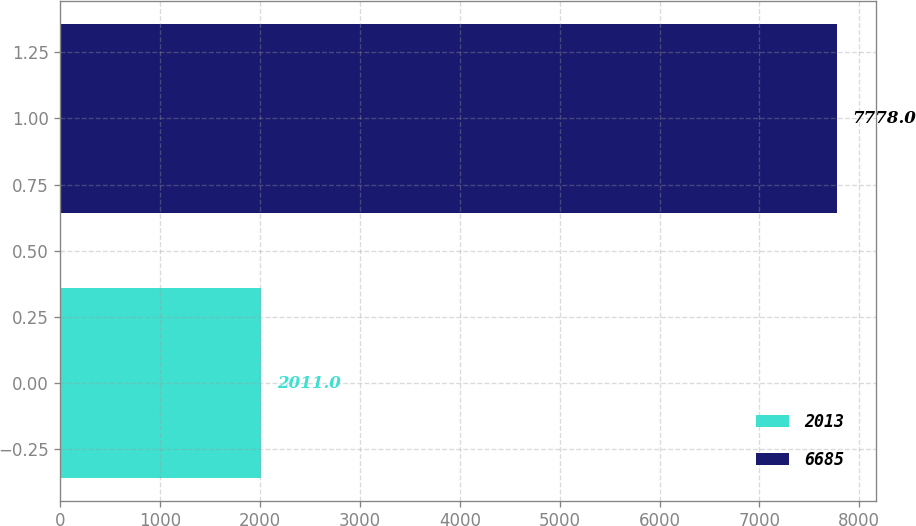Convert chart. <chart><loc_0><loc_0><loc_500><loc_500><bar_chart><fcel>2013<fcel>6685<nl><fcel>2011<fcel>7778<nl></chart> 